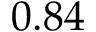Convert formula to latex. <formula><loc_0><loc_0><loc_500><loc_500>0 . 8 4</formula> 